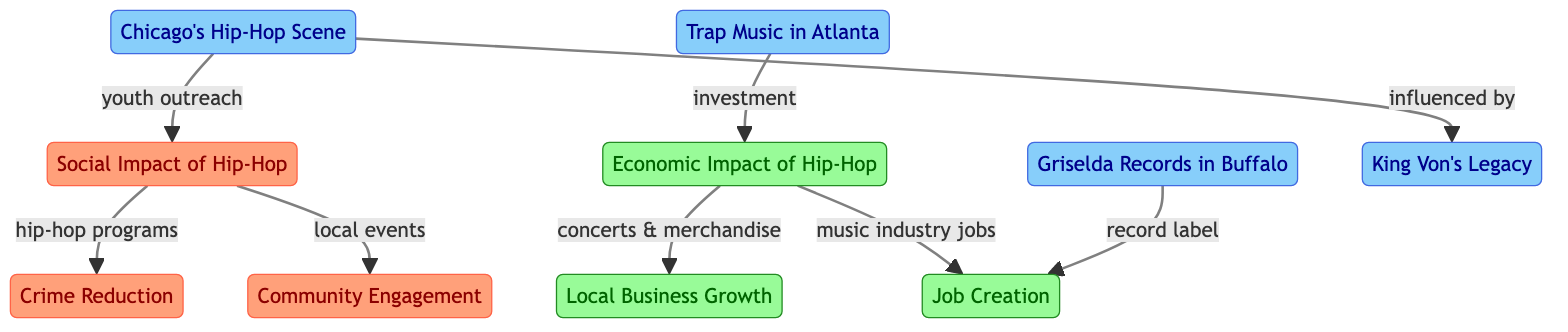What is the first node in the diagram? The first node is labeled "Social Impact of Hip-Hop." This can be determined by observing the top of the flowchart, where the first node is distinctly marked.
Answer: Social Impact of Hip-Hop How many case studies are presented in the diagram? There are four case studies indicated by the nodes: "Chicago's Hip-Hop Scene," "Trap Music in Atlanta," "Griselda Records in Buffalo," and "King Von's Legacy." Counting the highlighted case nodes gives a total of four.
Answer: 4 What is the relationship between local events and community engagement? The relationship is that local events contribute to community engagement, as depicted by the arrow pointing from "local events" to "Community Engagement" within the social impact section.
Answer: local events contribute to Which economic impact is related to concerts and merchandise? The economic impact related to concerts and merchandise is "Local Business Growth." This can be traced by following the connection stemming from "concerts & merchandise" to "Local Business Growth."
Answer: Local Business Growth Which specific legacy influenced Chicago's hip-hop scene? The specific legacy that influenced Chicago's hip-hop scene is "King Von's Legacy." This is shown by the arrow pointing from "influenced by" to "King Von's Legacy," linking the two directly.
Answer: King Von's Legacy Which nodes represent social impacts in the diagram? The social impact nodes in the diagram are "Crime Reduction," "Community Engagement," and "Social Impact of Hip-Hop." Identifying the colored sections marked as social allows us to locate these nodes effectively.
Answer: Crime Reduction, Community Engagement, Social Impact of Hip-Hop How do music industry jobs relate to the economic impact of hip-hop? Music industry jobs are directly connected to the economic impact noted as "Job Creation." This connection can be followed from the "music industry jobs" node, indicating its role in creating jobs economically.
Answer: Job Creation What type of business growth is associated with the hip-hop events? The type of business growth associated with the hip-hop events is "Local Business Growth." This shows the economic effect that hip-hop related events have on local businesses in urban communities.
Answer: Local Business Growth Which node represents a community engagement aspect influenced by hip-hop? The node that represents a community engagement aspect influenced by hip-hop is "Community Engagement." This node is linked directly to the broader "Social Impact of Hip-Hop" node.
Answer: Community Engagement 